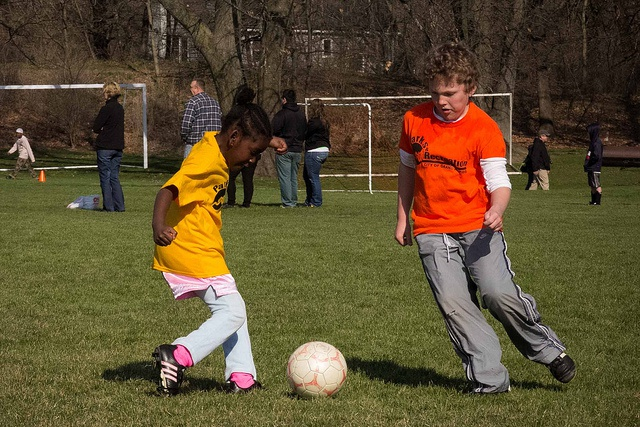Describe the objects in this image and their specific colors. I can see people in black, darkgray, and red tones, people in black, orange, lightgray, and maroon tones, people in black and gray tones, sports ball in black, ivory, and tan tones, and people in black, gray, purple, and darkgreen tones in this image. 